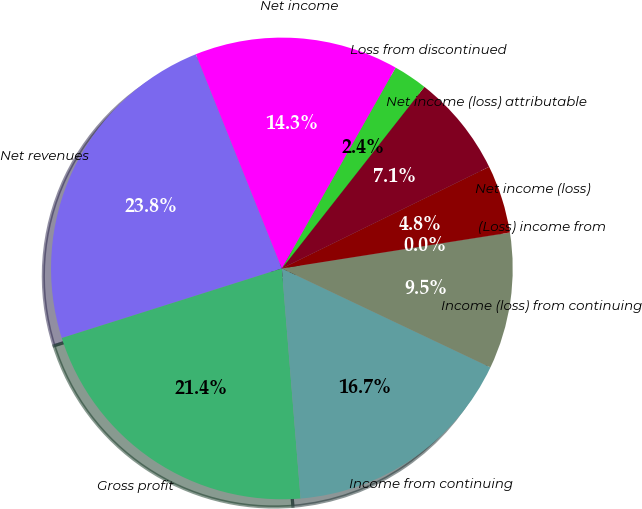<chart> <loc_0><loc_0><loc_500><loc_500><pie_chart><fcel>Net revenues<fcel>Gross profit<fcel>Income from continuing<fcel>Income (loss) from continuing<fcel>(Loss) income from<fcel>Net income (loss)<fcel>Net income (loss) attributable<fcel>Loss from discontinued<fcel>Net income<nl><fcel>23.8%<fcel>21.42%<fcel>16.66%<fcel>9.53%<fcel>0.01%<fcel>4.77%<fcel>7.15%<fcel>2.39%<fcel>14.28%<nl></chart> 